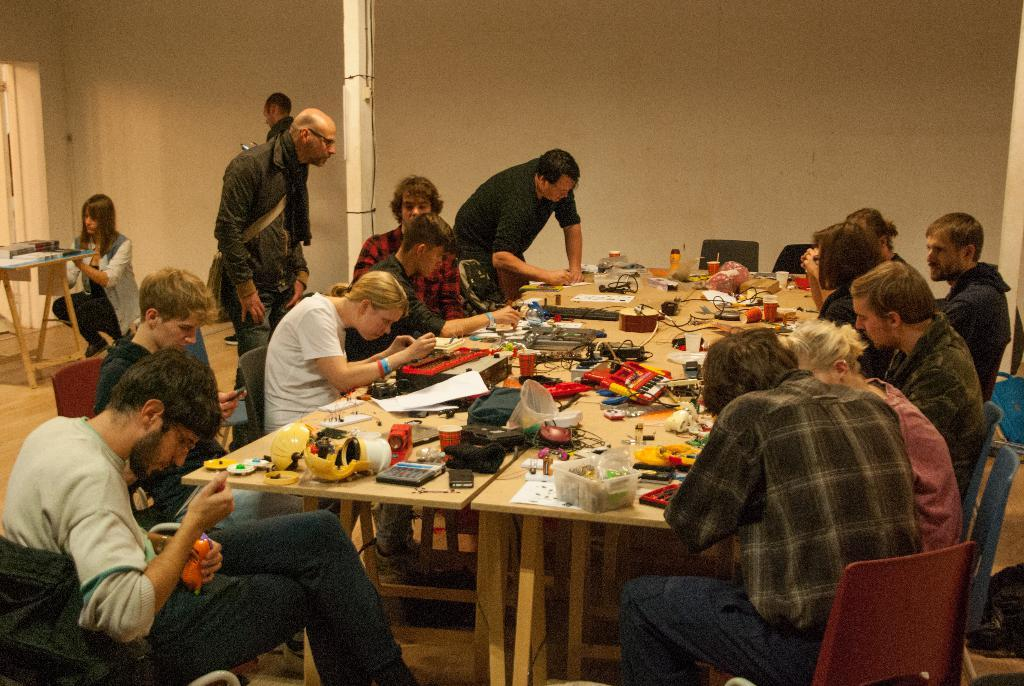What are the persons in the image doing? The persons in the image are sitting on a chair. What can be seen on the table in the image? There are things on the table in the image. How many persons are standing in the image? There are two persons standing in the image. What type of cream is being used by the person cooking in the image? There is no person cooking in the image, and therefore no cream is being used. How does the brake work on the chair in the image? The image does not show a chair with a brake mechanism, so it is not possible to answer this question. 